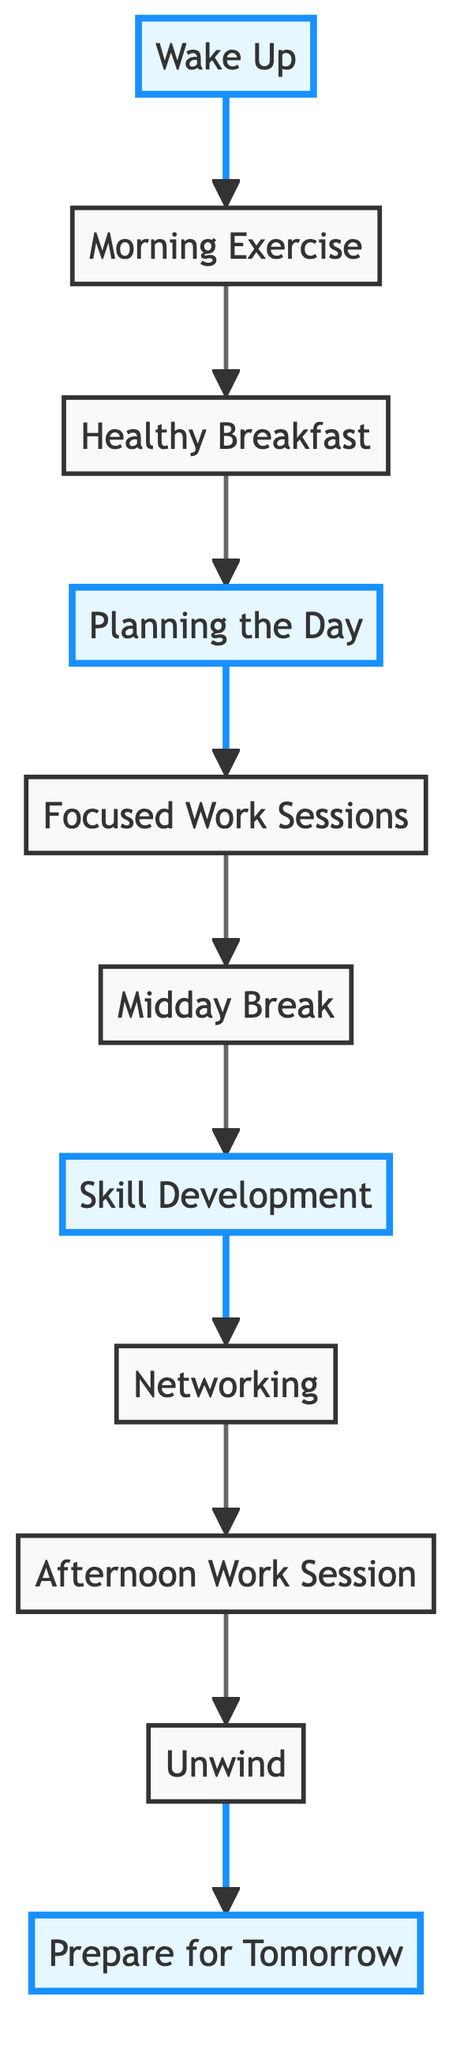What is the first activity in the daily routine? The first activity in the flow chart is labeled "Wake Up." It is the starting point, indicating the beginning of the daily routine for productivity and self-care.
Answer: Wake Up How many activities are listed in the diagram? By counting each node in the flow chart, there are a total of 11 activities shown, starting from "Wake Up" to "Prepare for Tomorrow."
Answer: 11 What activity follows "Midday Break"? In the flow chart, the activity that follows "Midday Break" is "Skill Development," indicating that after recharging, the focus shifts to enhancing one's skills.
Answer: Skill Development What is the last activity in the routine? The last activity in the flow chart is "Prepare for Tomorrow," which closes the daily routine, setting the stage for the next day.
Answer: Prepare for Tomorrow Which activities are highlighted in the diagram? The highlighted activities in the flow chart are "Wake Up," "Planning the Day," "Skill Development," and "Prepare for Tomorrow." These activities may signify key points of importance within the routine.
Answer: Wake Up, Planning the Day, Skill Development, Prepare for Tomorrow Which activity is conducted right before "Networking"? The activity that comes immediately before "Networking" in the flow chart is "Skill Development." This shows a logical progression from improving one's skills to building professional connections.
Answer: Skill Development How many breaks are in the daily routine? In the chart, there is one specified break labeled "Midday Break," which is indicated as a period of recharging during the day.
Answer: 1 What technique is suggested for better focus during work sessions? The flow chart mentions the "Pomodoro Technique" as a time management method to enhance focus during "Focused Work Sessions."
Answer: Pomodoro Technique What is the purpose of the activity "Unwind"? The activity "Unwind" is aimed at relaxing and reflecting, allowing one to decompress after a day of productivity.
Answer: Relax and reflect 